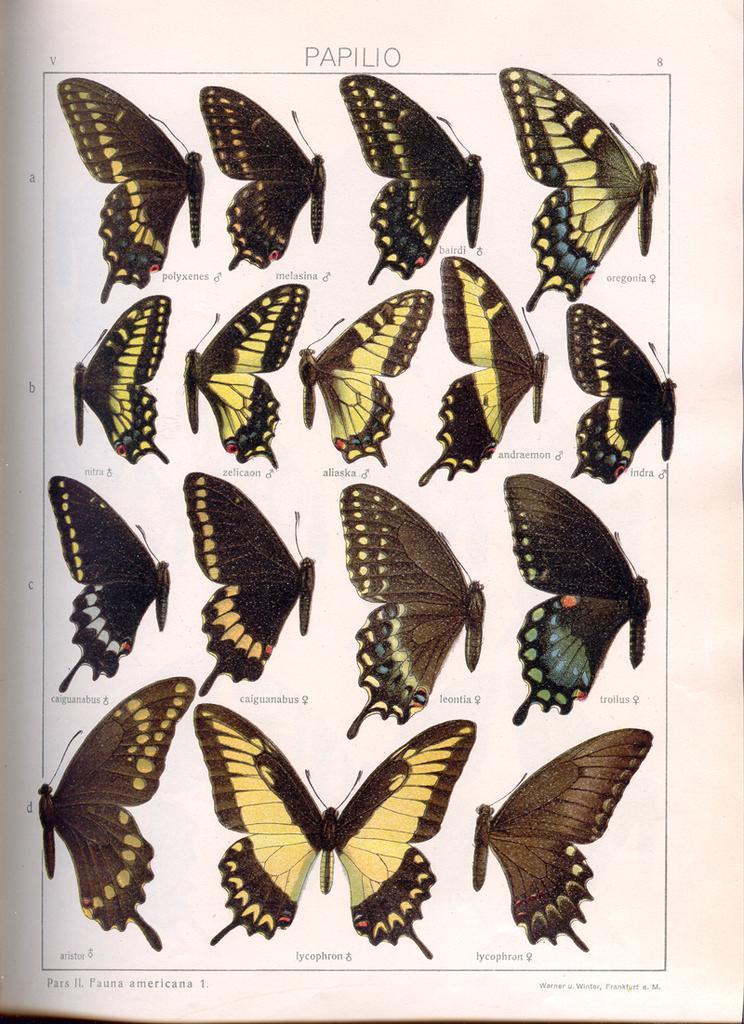Please provide a concise description of this image. In this image we can see a poster. We can see many butterflies and some text on the poster. 